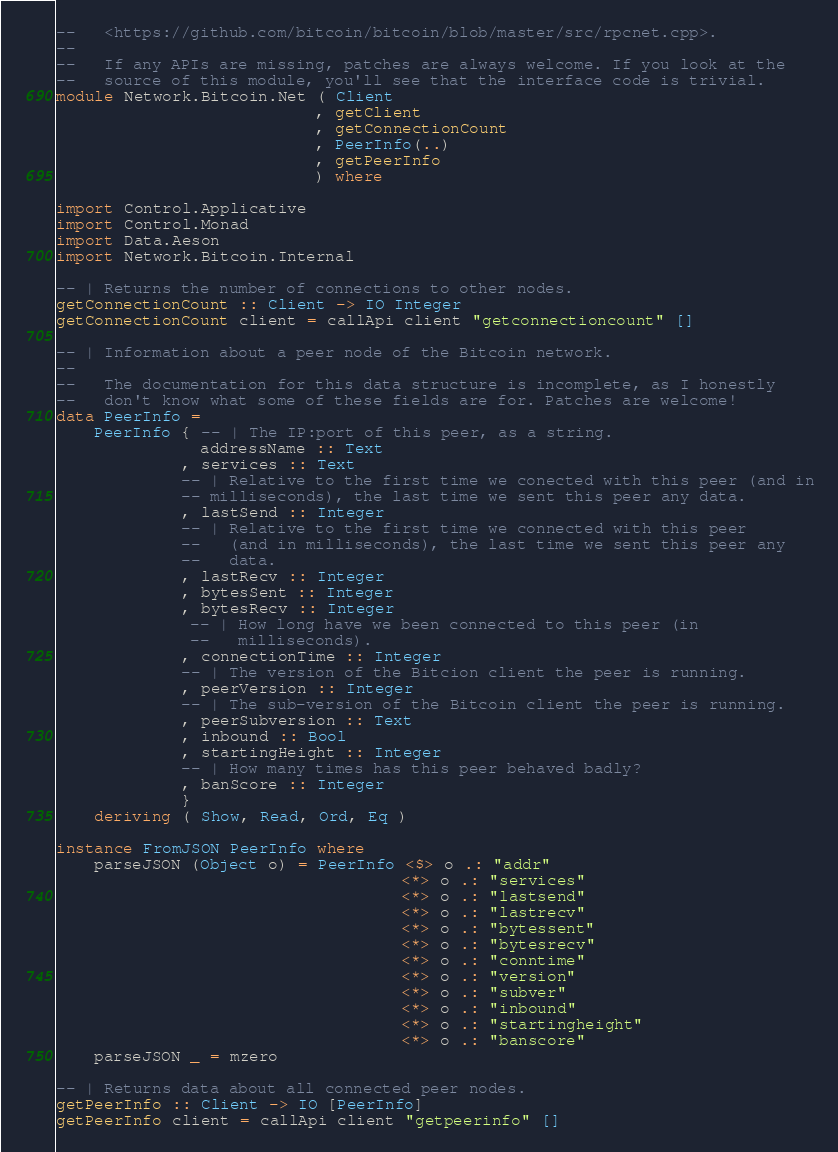<code> <loc_0><loc_0><loc_500><loc_500><_Haskell_>--   <https://github.com/bitcoin/bitcoin/blob/master/src/rpcnet.cpp>.
--
--   If any APIs are missing, patches are always welcome. If you look at the
--   source of this module, you'll see that the interface code is trivial.
module Network.Bitcoin.Net ( Client
                           , getClient
                           , getConnectionCount
                           , PeerInfo(..)
                           , getPeerInfo
                           ) where

import Control.Applicative
import Control.Monad
import Data.Aeson
import Network.Bitcoin.Internal

-- | Returns the number of connections to other nodes.
getConnectionCount :: Client -> IO Integer
getConnectionCount client = callApi client "getconnectioncount" []

-- | Information about a peer node of the Bitcoin network.
--
--   The documentation for this data structure is incomplete, as I honestly
--   don't know what some of these fields are for. Patches are welcome!
data PeerInfo =
    PeerInfo { -- | The IP:port of this peer, as a string.
               addressName :: Text
             , services :: Text
             -- | Relative to the first time we conected with this peer (and in
             -- milliseconds), the last time we sent this peer any data.
             , lastSend :: Integer
             -- | Relative to the first time we connected with this peer
             --   (and in milliseconds), the last time we sent this peer any
             --   data.
             , lastRecv :: Integer
             , bytesSent :: Integer
             , bytesRecv :: Integer
              -- | How long have we been connected to this peer (in
              --   milliseconds).
             , connectionTime :: Integer
             -- | The version of the Bitcion client the peer is running.
             , peerVersion :: Integer
             -- | The sub-version of the Bitcoin client the peer is running.
             , peerSubversion :: Text
             , inbound :: Bool
             , startingHeight :: Integer
             -- | How many times has this peer behaved badly?
             , banScore :: Integer
             }
    deriving ( Show, Read, Ord, Eq )

instance FromJSON PeerInfo where
    parseJSON (Object o) = PeerInfo <$> o .: "addr"
                                    <*> o .: "services"
                                    <*> o .: "lastsend"
                                    <*> o .: "lastrecv"
                                    <*> o .: "bytessent"
                                    <*> o .: "bytesrecv"
                                    <*> o .: "conntime"
                                    <*> o .: "version"
                                    <*> o .: "subver"
                                    <*> o .: "inbound"
                                    <*> o .: "startingheight"
                                    <*> o .: "banscore"
    parseJSON _ = mzero

-- | Returns data about all connected peer nodes.
getPeerInfo :: Client -> IO [PeerInfo]
getPeerInfo client = callApi client "getpeerinfo" []
</code> 